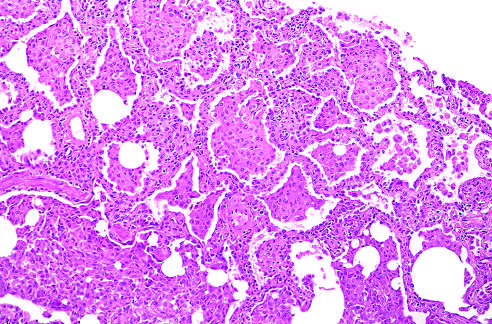where is the accumulation of large numbers of macrophages?
Answer the question using a single word or phrase. Within the alveolar spaces 